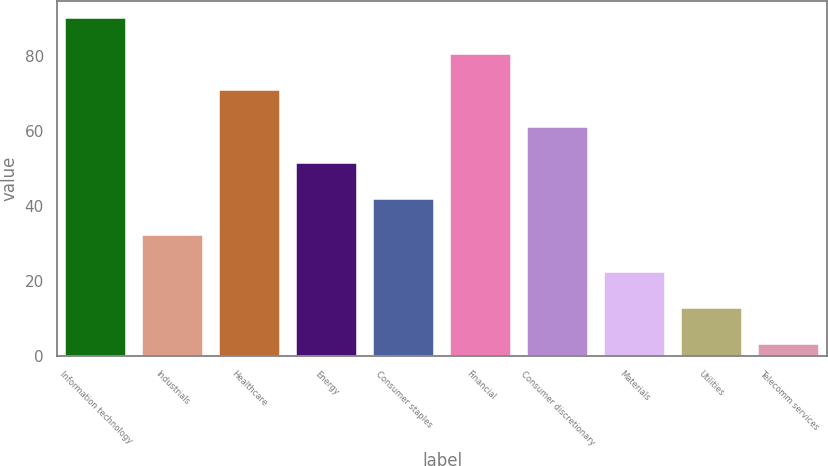Convert chart. <chart><loc_0><loc_0><loc_500><loc_500><bar_chart><fcel>Information technology<fcel>Industrials<fcel>Healthcare<fcel>Energy<fcel>Consumer staples<fcel>Financial<fcel>Consumer discretionary<fcel>Materials<fcel>Utilities<fcel>Telecomm services<nl><fcel>90.31<fcel>32.17<fcel>70.93<fcel>51.55<fcel>41.86<fcel>80.62<fcel>61.24<fcel>22.48<fcel>12.79<fcel>3.1<nl></chart> 